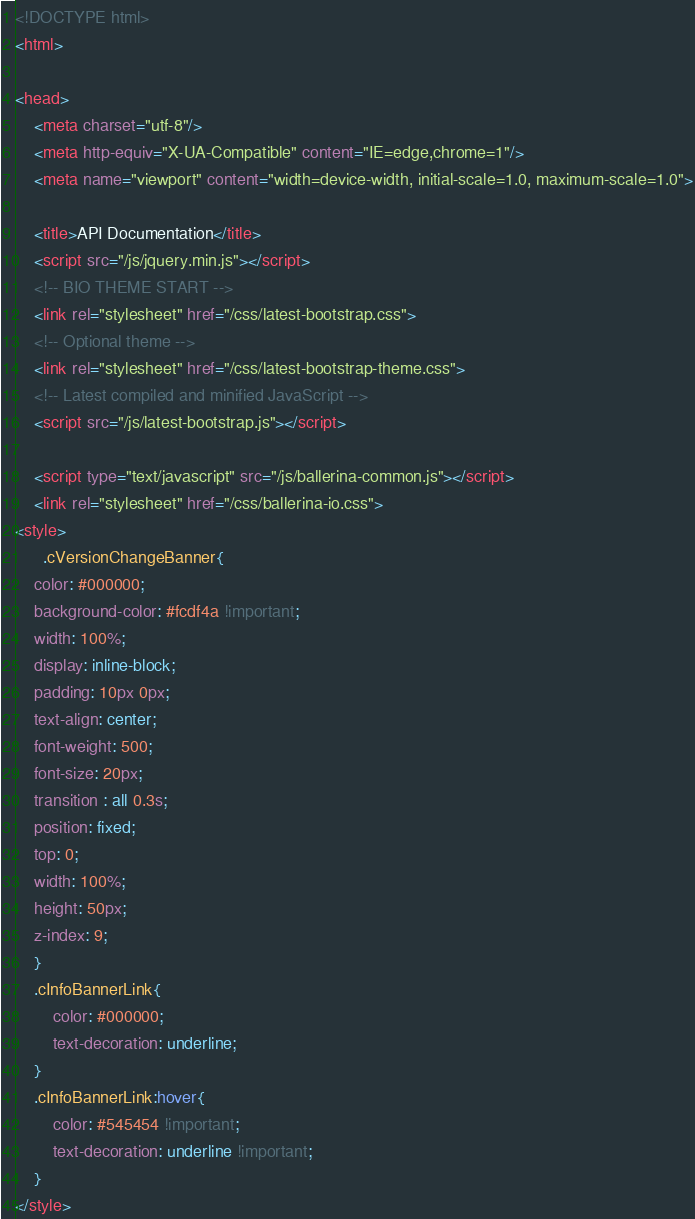Convert code to text. <code><loc_0><loc_0><loc_500><loc_500><_HTML_><!DOCTYPE html>
<html>

<head>
    <meta charset="utf-8"/>
    <meta http-equiv="X-UA-Compatible" content="IE=edge,chrome=1"/>
    <meta name="viewport" content="width=device-width, initial-scale=1.0, maximum-scale=1.0">

    <title>API Documentation</title>
    <script src="/js/jquery.min.js"></script>
    <!-- BIO THEME START -->
    <link rel="stylesheet" href="/css/latest-bootstrap.css">
    <!-- Optional theme -->
    <link rel="stylesheet" href="/css/latest-bootstrap-theme.css">
    <!-- Latest compiled and minified JavaScript -->
    <script src="/js/latest-bootstrap.js"></script>

    <script type="text/javascript" src="/js/ballerina-common.js"></script>
    <link rel="stylesheet" href="/css/ballerina-io.css">
<style>
      .cVersionChangeBanner{
    color: #000000;
    background-color: #fcdf4a !important;
    width: 100%;
    display: inline-block;
    padding: 10px 0px;
    text-align: center;
    font-weight: 500;
    font-size: 20px;
    transition : all 0.3s;
    position: fixed;
    top: 0;
    width: 100%;
    height: 50px;
    z-index: 9;
    }
    .cInfoBannerLink{
        color: #000000;
        text-decoration: underline;
    }
    .cInfoBannerLink:hover{
        color: #545454 !important;
        text-decoration: underline !important;
    }
</style>
</code> 